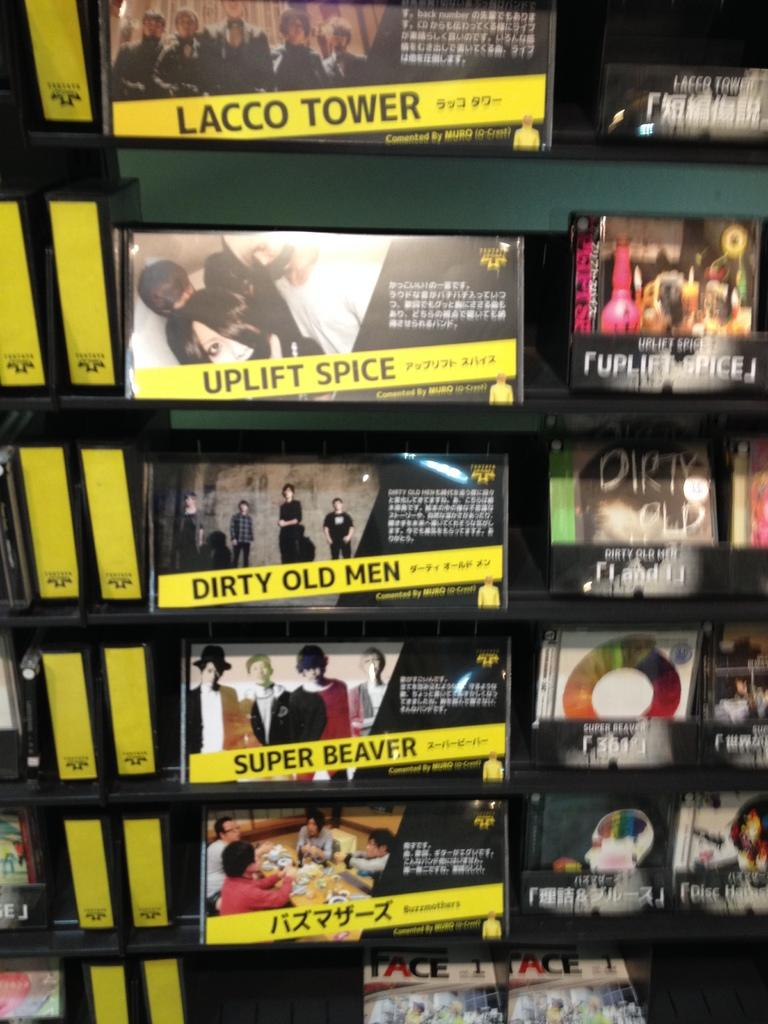<image>
Summarize the visual content of the image. An advertisement showing bands such as Uplift Spice and Dirty Old Men sits on a wall. 